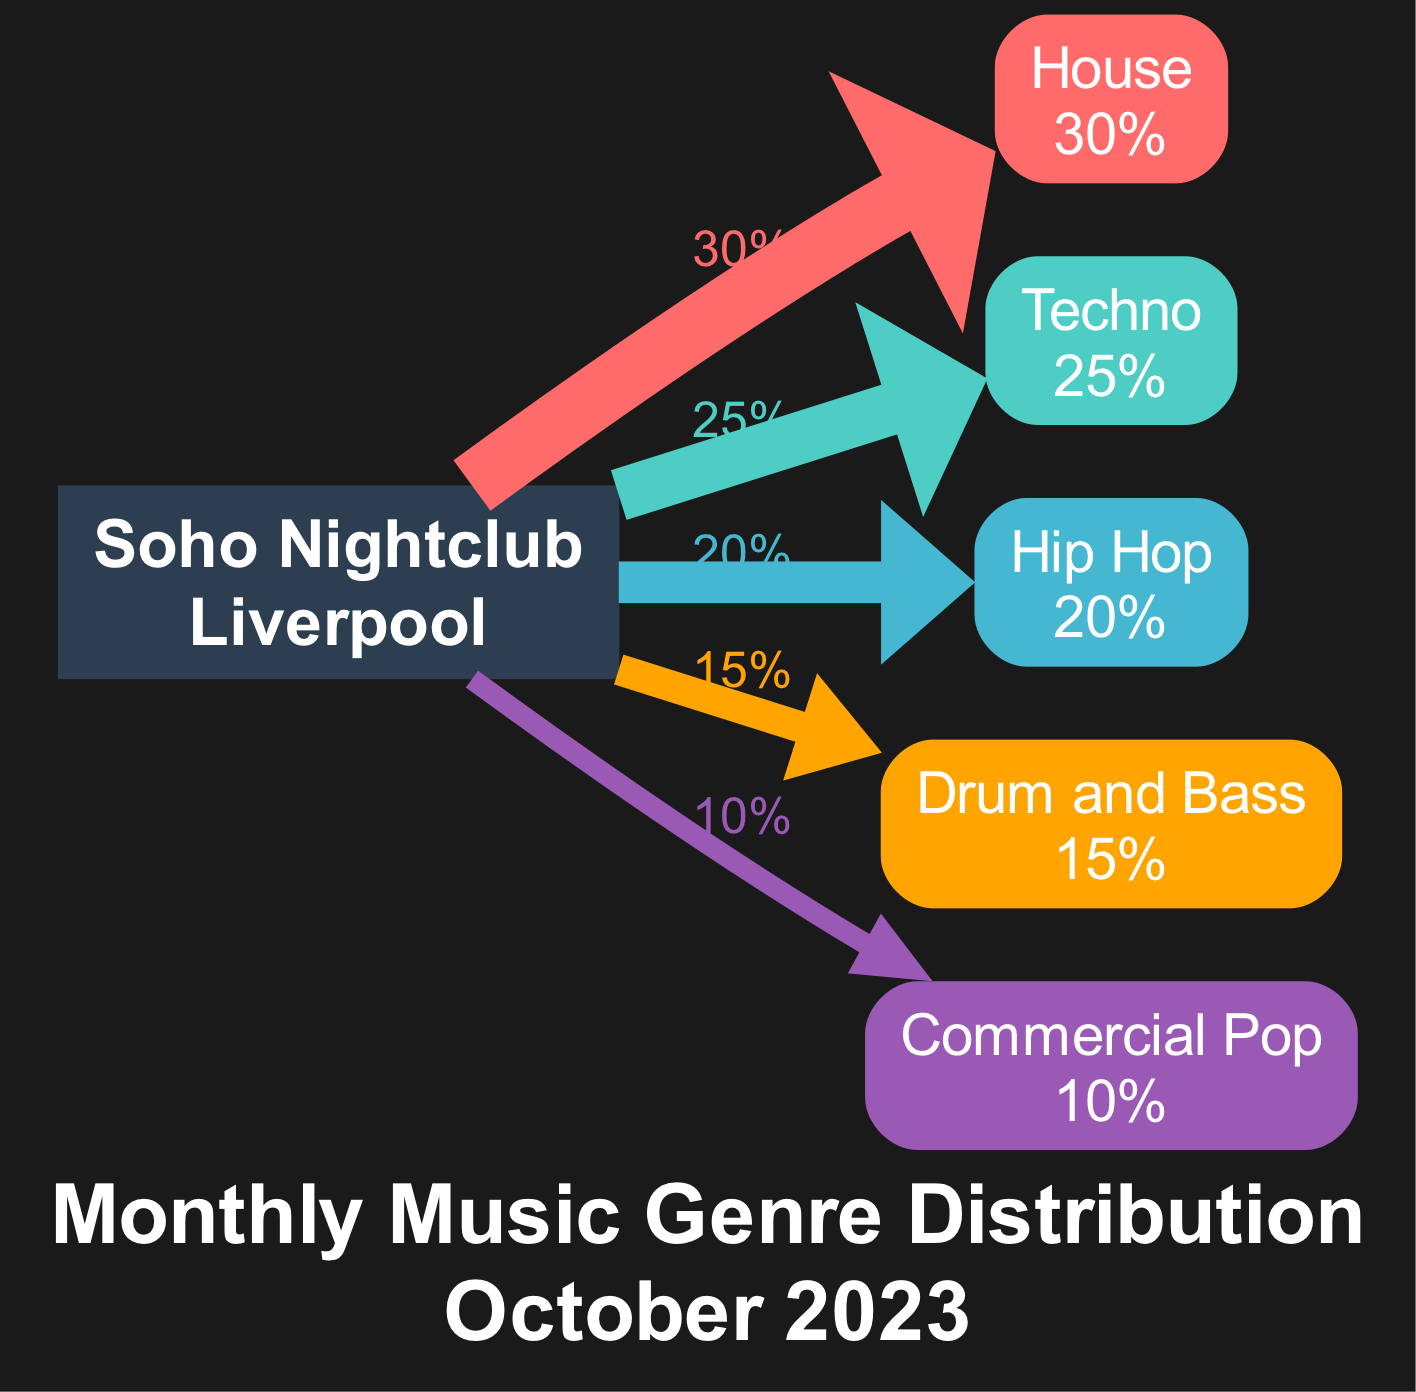What is the genre with the highest percentage? To find the genre with the highest percentage, I need to look at the percentages assigned to each genre in the diagram. The genre "House" is at 30%, which is the highest compared to the others.
Answer: House What percentage of the music played was Commercial Pop? The diagram indicates that "Commercial Pop" has a percentage of 10%. I directly refer to the node corresponding to this genre in the diagram.
Answer: 10% How many genres are represented in the diagram? The total number of genres can be counted by looking at the individual nodes depicted in the diagram. There are five distinct genres shown.
Answer: 5 Which genre has a percentage closest to Drum and Bass? To find out which genre is closest in percentage to "Drum and Bass," I compare the percentages listed. "Hip Hop" has 20%, while "Drum and Bass" has 15%. The closest is "Hip Hop."
Answer: Hip Hop What percentage of the overall music played was not House? To find this percentage, I subtract House's percentage from the total. The total is 100%, and House is 30%, so 100% - 30% gives me 70%.
Answer: 70% Which two genres combined make up 45% of the total? I will look through the percentages and find combinations that add up to 45%. "Techno" (25%) and "Hip Hop" (20%) add up to 45%.
Answer: Techno and Hip Hop What is the total percentage represented in the diagram? The total percentage is explicitly stated in the diagram as the sum of all genre percentages, which is presented as 100%.
Answer: 100% Which genre has the lowest representation in percentage? To determine which genre has the lowest percentage, I look at the percentages and see that "Commercial Pop" has the lowest at 10%.
Answer: Commercial Pop What is the main purpose of the Sankey Diagram in this context? The main purpose of the Sankey Diagram is to visually represent the distribution of different music genres played at the Soho nightclub over a given time period, which allows for an immediate understanding of genre popularity.
Answer: To visualize genre distribution 